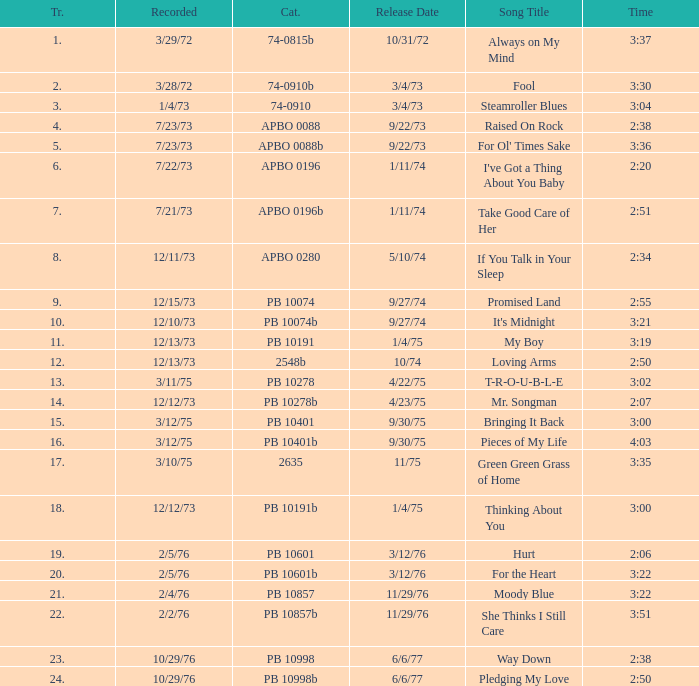Tell me the recorded for time of 2:50 and released date of 6/6/77 with track more than 20 10/29/76. 